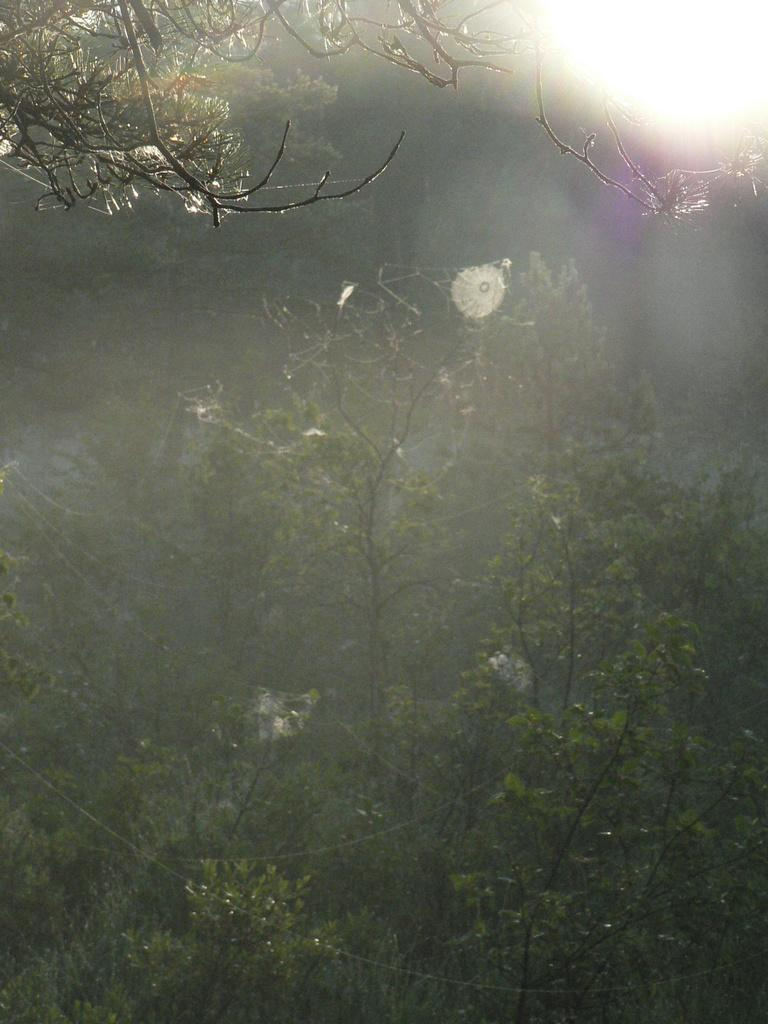What type of vegetation can be seen in the image? There are trees in the image. How would you describe the background of the image? The background of the image is blurry. What type of hook can be seen hanging from the tree in the image? There is no hook present in the image; it only features trees and a blurry background. 